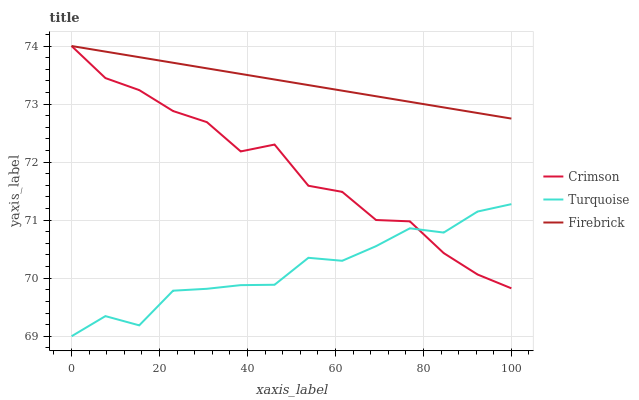Does Turquoise have the minimum area under the curve?
Answer yes or no. Yes. Does Firebrick have the maximum area under the curve?
Answer yes or no. Yes. Does Firebrick have the minimum area under the curve?
Answer yes or no. No. Does Turquoise have the maximum area under the curve?
Answer yes or no. No. Is Firebrick the smoothest?
Answer yes or no. Yes. Is Crimson the roughest?
Answer yes or no. Yes. Is Turquoise the smoothest?
Answer yes or no. No. Is Turquoise the roughest?
Answer yes or no. No. Does Turquoise have the lowest value?
Answer yes or no. Yes. Does Firebrick have the lowest value?
Answer yes or no. No. Does Firebrick have the highest value?
Answer yes or no. Yes. Does Turquoise have the highest value?
Answer yes or no. No. Is Turquoise less than Firebrick?
Answer yes or no. Yes. Is Firebrick greater than Turquoise?
Answer yes or no. Yes. Does Turquoise intersect Crimson?
Answer yes or no. Yes. Is Turquoise less than Crimson?
Answer yes or no. No. Is Turquoise greater than Crimson?
Answer yes or no. No. Does Turquoise intersect Firebrick?
Answer yes or no. No. 